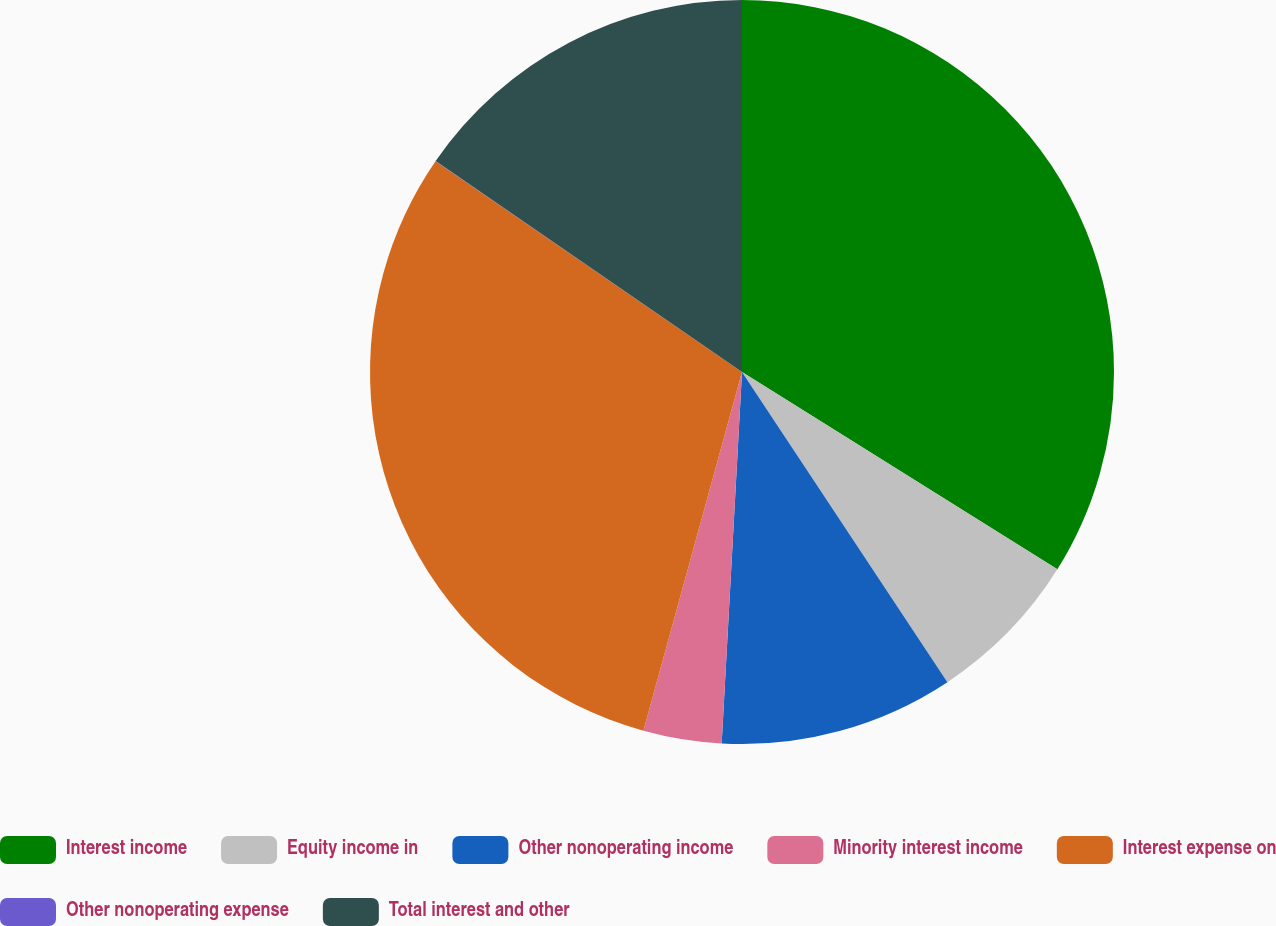Convert chart. <chart><loc_0><loc_0><loc_500><loc_500><pie_chart><fcel>Interest income<fcel>Equity income in<fcel>Other nonoperating income<fcel>Minority interest income<fcel>Interest expense on<fcel>Other nonoperating expense<fcel>Total interest and other<nl><fcel>33.9%<fcel>6.79%<fcel>10.18%<fcel>3.4%<fcel>30.32%<fcel>0.01%<fcel>15.4%<nl></chart> 